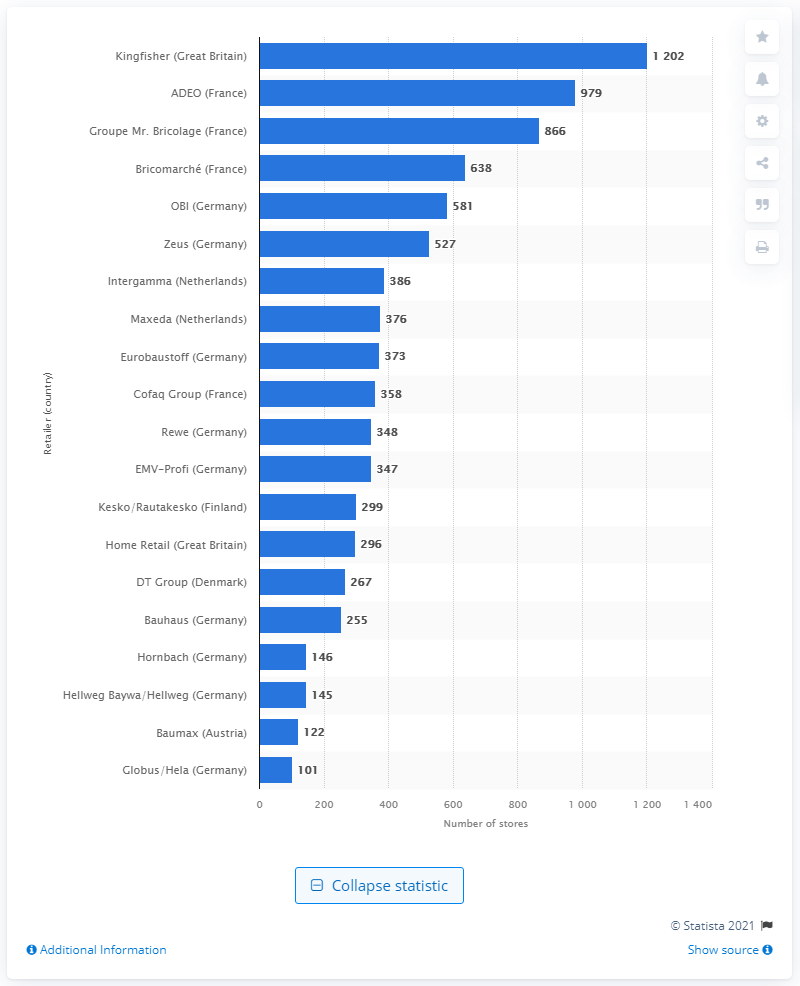How many stores did Kingfisher operate in 2014?
 1202 